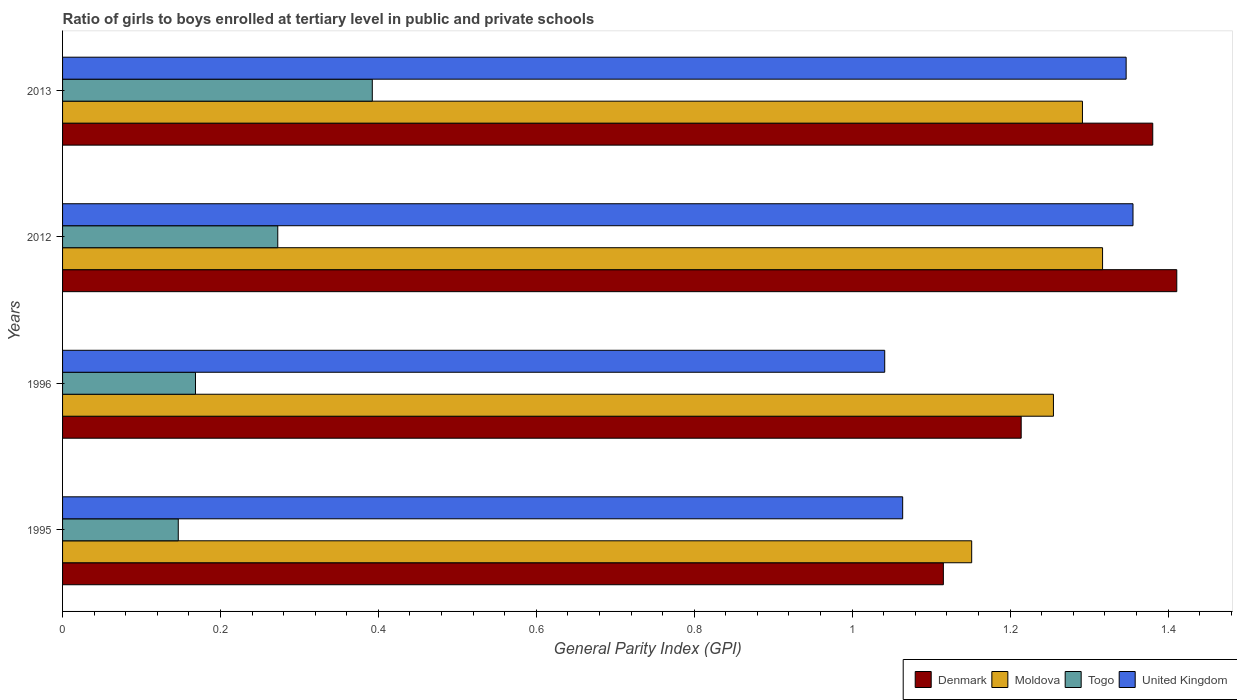How many different coloured bars are there?
Give a very brief answer. 4. Are the number of bars per tick equal to the number of legend labels?
Provide a succinct answer. Yes. Are the number of bars on each tick of the Y-axis equal?
Your answer should be compact. Yes. How many bars are there on the 1st tick from the top?
Provide a short and direct response. 4. How many bars are there on the 3rd tick from the bottom?
Provide a succinct answer. 4. What is the general parity index in Togo in 2013?
Provide a short and direct response. 0.39. Across all years, what is the maximum general parity index in Togo?
Your answer should be compact. 0.39. Across all years, what is the minimum general parity index in Denmark?
Your response must be concise. 1.12. In which year was the general parity index in Denmark minimum?
Offer a very short reply. 1995. What is the total general parity index in United Kingdom in the graph?
Provide a succinct answer. 4.81. What is the difference between the general parity index in United Kingdom in 1996 and that in 2012?
Give a very brief answer. -0.31. What is the difference between the general parity index in Moldova in 1996 and the general parity index in United Kingdom in 2012?
Ensure brevity in your answer.  -0.1. What is the average general parity index in Moldova per year?
Offer a very short reply. 1.25. In the year 2012, what is the difference between the general parity index in Moldova and general parity index in Togo?
Your answer should be very brief. 1.04. What is the ratio of the general parity index in United Kingdom in 1995 to that in 2012?
Keep it short and to the point. 0.78. Is the general parity index in Denmark in 1996 less than that in 2012?
Your answer should be compact. Yes. What is the difference between the highest and the second highest general parity index in Togo?
Offer a very short reply. 0.12. What is the difference between the highest and the lowest general parity index in Denmark?
Your answer should be compact. 0.3. In how many years, is the general parity index in Moldova greater than the average general parity index in Moldova taken over all years?
Make the answer very short. 3. What does the 2nd bar from the bottom in 2012 represents?
Provide a succinct answer. Moldova. Is it the case that in every year, the sum of the general parity index in Denmark and general parity index in United Kingdom is greater than the general parity index in Moldova?
Provide a short and direct response. Yes. How many bars are there?
Your answer should be very brief. 16. Are all the bars in the graph horizontal?
Ensure brevity in your answer.  Yes. What is the difference between two consecutive major ticks on the X-axis?
Provide a short and direct response. 0.2. Are the values on the major ticks of X-axis written in scientific E-notation?
Ensure brevity in your answer.  No. How many legend labels are there?
Offer a very short reply. 4. What is the title of the graph?
Offer a terse response. Ratio of girls to boys enrolled at tertiary level in public and private schools. What is the label or title of the X-axis?
Give a very brief answer. General Parity Index (GPI). What is the General Parity Index (GPI) of Denmark in 1995?
Your response must be concise. 1.12. What is the General Parity Index (GPI) of Moldova in 1995?
Offer a very short reply. 1.15. What is the General Parity Index (GPI) of Togo in 1995?
Offer a terse response. 0.15. What is the General Parity Index (GPI) in United Kingdom in 1995?
Give a very brief answer. 1.06. What is the General Parity Index (GPI) in Denmark in 1996?
Provide a succinct answer. 1.21. What is the General Parity Index (GPI) in Moldova in 1996?
Offer a very short reply. 1.25. What is the General Parity Index (GPI) in Togo in 1996?
Provide a succinct answer. 0.17. What is the General Parity Index (GPI) in United Kingdom in 1996?
Your answer should be compact. 1.04. What is the General Parity Index (GPI) of Denmark in 2012?
Your answer should be compact. 1.41. What is the General Parity Index (GPI) in Moldova in 2012?
Your response must be concise. 1.32. What is the General Parity Index (GPI) of Togo in 2012?
Your answer should be compact. 0.27. What is the General Parity Index (GPI) in United Kingdom in 2012?
Your response must be concise. 1.36. What is the General Parity Index (GPI) in Denmark in 2013?
Offer a terse response. 1.38. What is the General Parity Index (GPI) of Moldova in 2013?
Give a very brief answer. 1.29. What is the General Parity Index (GPI) in Togo in 2013?
Offer a terse response. 0.39. What is the General Parity Index (GPI) of United Kingdom in 2013?
Your answer should be compact. 1.35. Across all years, what is the maximum General Parity Index (GPI) of Denmark?
Ensure brevity in your answer.  1.41. Across all years, what is the maximum General Parity Index (GPI) of Moldova?
Make the answer very short. 1.32. Across all years, what is the maximum General Parity Index (GPI) of Togo?
Your answer should be compact. 0.39. Across all years, what is the maximum General Parity Index (GPI) of United Kingdom?
Provide a short and direct response. 1.36. Across all years, what is the minimum General Parity Index (GPI) in Denmark?
Keep it short and to the point. 1.12. Across all years, what is the minimum General Parity Index (GPI) of Moldova?
Offer a very short reply. 1.15. Across all years, what is the minimum General Parity Index (GPI) in Togo?
Your response must be concise. 0.15. Across all years, what is the minimum General Parity Index (GPI) of United Kingdom?
Give a very brief answer. 1.04. What is the total General Parity Index (GPI) in Denmark in the graph?
Provide a succinct answer. 5.12. What is the total General Parity Index (GPI) in Moldova in the graph?
Offer a very short reply. 5.02. What is the total General Parity Index (GPI) of Togo in the graph?
Give a very brief answer. 0.98. What is the total General Parity Index (GPI) in United Kingdom in the graph?
Provide a short and direct response. 4.81. What is the difference between the General Parity Index (GPI) of Denmark in 1995 and that in 1996?
Provide a short and direct response. -0.1. What is the difference between the General Parity Index (GPI) of Moldova in 1995 and that in 1996?
Your response must be concise. -0.1. What is the difference between the General Parity Index (GPI) of Togo in 1995 and that in 1996?
Your answer should be compact. -0.02. What is the difference between the General Parity Index (GPI) in United Kingdom in 1995 and that in 1996?
Give a very brief answer. 0.02. What is the difference between the General Parity Index (GPI) in Denmark in 1995 and that in 2012?
Your answer should be compact. -0.3. What is the difference between the General Parity Index (GPI) of Moldova in 1995 and that in 2012?
Provide a short and direct response. -0.17. What is the difference between the General Parity Index (GPI) of Togo in 1995 and that in 2012?
Ensure brevity in your answer.  -0.13. What is the difference between the General Parity Index (GPI) of United Kingdom in 1995 and that in 2012?
Make the answer very short. -0.29. What is the difference between the General Parity Index (GPI) of Denmark in 1995 and that in 2013?
Your answer should be very brief. -0.27. What is the difference between the General Parity Index (GPI) of Moldova in 1995 and that in 2013?
Provide a succinct answer. -0.14. What is the difference between the General Parity Index (GPI) of Togo in 1995 and that in 2013?
Provide a succinct answer. -0.25. What is the difference between the General Parity Index (GPI) in United Kingdom in 1995 and that in 2013?
Make the answer very short. -0.28. What is the difference between the General Parity Index (GPI) in Denmark in 1996 and that in 2012?
Your answer should be very brief. -0.2. What is the difference between the General Parity Index (GPI) in Moldova in 1996 and that in 2012?
Your answer should be compact. -0.06. What is the difference between the General Parity Index (GPI) in Togo in 1996 and that in 2012?
Make the answer very short. -0.1. What is the difference between the General Parity Index (GPI) in United Kingdom in 1996 and that in 2012?
Make the answer very short. -0.31. What is the difference between the General Parity Index (GPI) of Denmark in 1996 and that in 2013?
Your answer should be compact. -0.17. What is the difference between the General Parity Index (GPI) of Moldova in 1996 and that in 2013?
Provide a succinct answer. -0.04. What is the difference between the General Parity Index (GPI) of Togo in 1996 and that in 2013?
Your answer should be very brief. -0.22. What is the difference between the General Parity Index (GPI) of United Kingdom in 1996 and that in 2013?
Ensure brevity in your answer.  -0.31. What is the difference between the General Parity Index (GPI) of Denmark in 2012 and that in 2013?
Your answer should be very brief. 0.03. What is the difference between the General Parity Index (GPI) in Moldova in 2012 and that in 2013?
Provide a short and direct response. 0.03. What is the difference between the General Parity Index (GPI) in Togo in 2012 and that in 2013?
Offer a terse response. -0.12. What is the difference between the General Parity Index (GPI) in United Kingdom in 2012 and that in 2013?
Your answer should be compact. 0.01. What is the difference between the General Parity Index (GPI) in Denmark in 1995 and the General Parity Index (GPI) in Moldova in 1996?
Provide a short and direct response. -0.14. What is the difference between the General Parity Index (GPI) of Denmark in 1995 and the General Parity Index (GPI) of Togo in 1996?
Make the answer very short. 0.95. What is the difference between the General Parity Index (GPI) of Denmark in 1995 and the General Parity Index (GPI) of United Kingdom in 1996?
Provide a succinct answer. 0.07. What is the difference between the General Parity Index (GPI) in Moldova in 1995 and the General Parity Index (GPI) in Togo in 1996?
Your response must be concise. 0.98. What is the difference between the General Parity Index (GPI) of Moldova in 1995 and the General Parity Index (GPI) of United Kingdom in 1996?
Provide a succinct answer. 0.11. What is the difference between the General Parity Index (GPI) of Togo in 1995 and the General Parity Index (GPI) of United Kingdom in 1996?
Your answer should be very brief. -0.89. What is the difference between the General Parity Index (GPI) in Denmark in 1995 and the General Parity Index (GPI) in Moldova in 2012?
Give a very brief answer. -0.2. What is the difference between the General Parity Index (GPI) of Denmark in 1995 and the General Parity Index (GPI) of Togo in 2012?
Ensure brevity in your answer.  0.84. What is the difference between the General Parity Index (GPI) in Denmark in 1995 and the General Parity Index (GPI) in United Kingdom in 2012?
Your answer should be compact. -0.24. What is the difference between the General Parity Index (GPI) in Moldova in 1995 and the General Parity Index (GPI) in Togo in 2012?
Ensure brevity in your answer.  0.88. What is the difference between the General Parity Index (GPI) of Moldova in 1995 and the General Parity Index (GPI) of United Kingdom in 2012?
Provide a succinct answer. -0.2. What is the difference between the General Parity Index (GPI) in Togo in 1995 and the General Parity Index (GPI) in United Kingdom in 2012?
Your answer should be very brief. -1.21. What is the difference between the General Parity Index (GPI) of Denmark in 1995 and the General Parity Index (GPI) of Moldova in 2013?
Give a very brief answer. -0.18. What is the difference between the General Parity Index (GPI) in Denmark in 1995 and the General Parity Index (GPI) in Togo in 2013?
Your response must be concise. 0.72. What is the difference between the General Parity Index (GPI) in Denmark in 1995 and the General Parity Index (GPI) in United Kingdom in 2013?
Make the answer very short. -0.23. What is the difference between the General Parity Index (GPI) of Moldova in 1995 and the General Parity Index (GPI) of Togo in 2013?
Offer a very short reply. 0.76. What is the difference between the General Parity Index (GPI) of Moldova in 1995 and the General Parity Index (GPI) of United Kingdom in 2013?
Ensure brevity in your answer.  -0.2. What is the difference between the General Parity Index (GPI) of Togo in 1995 and the General Parity Index (GPI) of United Kingdom in 2013?
Give a very brief answer. -1.2. What is the difference between the General Parity Index (GPI) in Denmark in 1996 and the General Parity Index (GPI) in Moldova in 2012?
Make the answer very short. -0.1. What is the difference between the General Parity Index (GPI) of Denmark in 1996 and the General Parity Index (GPI) of Togo in 2012?
Offer a terse response. 0.94. What is the difference between the General Parity Index (GPI) of Denmark in 1996 and the General Parity Index (GPI) of United Kingdom in 2012?
Ensure brevity in your answer.  -0.14. What is the difference between the General Parity Index (GPI) of Moldova in 1996 and the General Parity Index (GPI) of Togo in 2012?
Make the answer very short. 0.98. What is the difference between the General Parity Index (GPI) of Moldova in 1996 and the General Parity Index (GPI) of United Kingdom in 2012?
Provide a succinct answer. -0.1. What is the difference between the General Parity Index (GPI) of Togo in 1996 and the General Parity Index (GPI) of United Kingdom in 2012?
Provide a short and direct response. -1.19. What is the difference between the General Parity Index (GPI) in Denmark in 1996 and the General Parity Index (GPI) in Moldova in 2013?
Offer a terse response. -0.08. What is the difference between the General Parity Index (GPI) in Denmark in 1996 and the General Parity Index (GPI) in Togo in 2013?
Offer a terse response. 0.82. What is the difference between the General Parity Index (GPI) in Denmark in 1996 and the General Parity Index (GPI) in United Kingdom in 2013?
Provide a short and direct response. -0.13. What is the difference between the General Parity Index (GPI) of Moldova in 1996 and the General Parity Index (GPI) of Togo in 2013?
Keep it short and to the point. 0.86. What is the difference between the General Parity Index (GPI) in Moldova in 1996 and the General Parity Index (GPI) in United Kingdom in 2013?
Make the answer very short. -0.09. What is the difference between the General Parity Index (GPI) of Togo in 1996 and the General Parity Index (GPI) of United Kingdom in 2013?
Offer a very short reply. -1.18. What is the difference between the General Parity Index (GPI) of Denmark in 2012 and the General Parity Index (GPI) of Moldova in 2013?
Provide a succinct answer. 0.12. What is the difference between the General Parity Index (GPI) of Denmark in 2012 and the General Parity Index (GPI) of Togo in 2013?
Your answer should be compact. 1.02. What is the difference between the General Parity Index (GPI) of Denmark in 2012 and the General Parity Index (GPI) of United Kingdom in 2013?
Offer a terse response. 0.06. What is the difference between the General Parity Index (GPI) in Moldova in 2012 and the General Parity Index (GPI) in Togo in 2013?
Make the answer very short. 0.92. What is the difference between the General Parity Index (GPI) of Moldova in 2012 and the General Parity Index (GPI) of United Kingdom in 2013?
Keep it short and to the point. -0.03. What is the difference between the General Parity Index (GPI) in Togo in 2012 and the General Parity Index (GPI) in United Kingdom in 2013?
Your answer should be very brief. -1.07. What is the average General Parity Index (GPI) of Denmark per year?
Offer a very short reply. 1.28. What is the average General Parity Index (GPI) in Moldova per year?
Keep it short and to the point. 1.25. What is the average General Parity Index (GPI) of Togo per year?
Provide a succinct answer. 0.24. What is the average General Parity Index (GPI) in United Kingdom per year?
Your response must be concise. 1.2. In the year 1995, what is the difference between the General Parity Index (GPI) of Denmark and General Parity Index (GPI) of Moldova?
Make the answer very short. -0.04. In the year 1995, what is the difference between the General Parity Index (GPI) of Denmark and General Parity Index (GPI) of Togo?
Your answer should be compact. 0.97. In the year 1995, what is the difference between the General Parity Index (GPI) in Denmark and General Parity Index (GPI) in United Kingdom?
Make the answer very short. 0.05. In the year 1995, what is the difference between the General Parity Index (GPI) of Moldova and General Parity Index (GPI) of United Kingdom?
Make the answer very short. 0.09. In the year 1995, what is the difference between the General Parity Index (GPI) of Togo and General Parity Index (GPI) of United Kingdom?
Give a very brief answer. -0.92. In the year 1996, what is the difference between the General Parity Index (GPI) in Denmark and General Parity Index (GPI) in Moldova?
Your response must be concise. -0.04. In the year 1996, what is the difference between the General Parity Index (GPI) of Denmark and General Parity Index (GPI) of Togo?
Ensure brevity in your answer.  1.05. In the year 1996, what is the difference between the General Parity Index (GPI) in Denmark and General Parity Index (GPI) in United Kingdom?
Give a very brief answer. 0.17. In the year 1996, what is the difference between the General Parity Index (GPI) of Moldova and General Parity Index (GPI) of Togo?
Give a very brief answer. 1.09. In the year 1996, what is the difference between the General Parity Index (GPI) of Moldova and General Parity Index (GPI) of United Kingdom?
Make the answer very short. 0.21. In the year 1996, what is the difference between the General Parity Index (GPI) of Togo and General Parity Index (GPI) of United Kingdom?
Your answer should be very brief. -0.87. In the year 2012, what is the difference between the General Parity Index (GPI) in Denmark and General Parity Index (GPI) in Moldova?
Make the answer very short. 0.09. In the year 2012, what is the difference between the General Parity Index (GPI) in Denmark and General Parity Index (GPI) in Togo?
Give a very brief answer. 1.14. In the year 2012, what is the difference between the General Parity Index (GPI) in Denmark and General Parity Index (GPI) in United Kingdom?
Provide a succinct answer. 0.06. In the year 2012, what is the difference between the General Parity Index (GPI) in Moldova and General Parity Index (GPI) in Togo?
Your answer should be compact. 1.04. In the year 2012, what is the difference between the General Parity Index (GPI) in Moldova and General Parity Index (GPI) in United Kingdom?
Make the answer very short. -0.04. In the year 2012, what is the difference between the General Parity Index (GPI) of Togo and General Parity Index (GPI) of United Kingdom?
Offer a very short reply. -1.08. In the year 2013, what is the difference between the General Parity Index (GPI) in Denmark and General Parity Index (GPI) in Moldova?
Provide a succinct answer. 0.09. In the year 2013, what is the difference between the General Parity Index (GPI) in Denmark and General Parity Index (GPI) in Togo?
Give a very brief answer. 0.99. In the year 2013, what is the difference between the General Parity Index (GPI) in Denmark and General Parity Index (GPI) in United Kingdom?
Your answer should be very brief. 0.03. In the year 2013, what is the difference between the General Parity Index (GPI) of Moldova and General Parity Index (GPI) of Togo?
Your answer should be very brief. 0.9. In the year 2013, what is the difference between the General Parity Index (GPI) of Moldova and General Parity Index (GPI) of United Kingdom?
Offer a terse response. -0.06. In the year 2013, what is the difference between the General Parity Index (GPI) of Togo and General Parity Index (GPI) of United Kingdom?
Your answer should be compact. -0.95. What is the ratio of the General Parity Index (GPI) in Denmark in 1995 to that in 1996?
Offer a terse response. 0.92. What is the ratio of the General Parity Index (GPI) in Moldova in 1995 to that in 1996?
Make the answer very short. 0.92. What is the ratio of the General Parity Index (GPI) of Togo in 1995 to that in 1996?
Ensure brevity in your answer.  0.87. What is the ratio of the General Parity Index (GPI) of United Kingdom in 1995 to that in 1996?
Offer a terse response. 1.02. What is the ratio of the General Parity Index (GPI) in Denmark in 1995 to that in 2012?
Offer a terse response. 0.79. What is the ratio of the General Parity Index (GPI) of Moldova in 1995 to that in 2012?
Your response must be concise. 0.87. What is the ratio of the General Parity Index (GPI) of Togo in 1995 to that in 2012?
Your answer should be compact. 0.54. What is the ratio of the General Parity Index (GPI) of United Kingdom in 1995 to that in 2012?
Provide a succinct answer. 0.78. What is the ratio of the General Parity Index (GPI) of Denmark in 1995 to that in 2013?
Offer a very short reply. 0.81. What is the ratio of the General Parity Index (GPI) in Moldova in 1995 to that in 2013?
Provide a short and direct response. 0.89. What is the ratio of the General Parity Index (GPI) of Togo in 1995 to that in 2013?
Your response must be concise. 0.37. What is the ratio of the General Parity Index (GPI) of United Kingdom in 1995 to that in 2013?
Your response must be concise. 0.79. What is the ratio of the General Parity Index (GPI) of Denmark in 1996 to that in 2012?
Offer a very short reply. 0.86. What is the ratio of the General Parity Index (GPI) of Moldova in 1996 to that in 2012?
Keep it short and to the point. 0.95. What is the ratio of the General Parity Index (GPI) in Togo in 1996 to that in 2012?
Ensure brevity in your answer.  0.62. What is the ratio of the General Parity Index (GPI) in United Kingdom in 1996 to that in 2012?
Your answer should be very brief. 0.77. What is the ratio of the General Parity Index (GPI) in Denmark in 1996 to that in 2013?
Keep it short and to the point. 0.88. What is the ratio of the General Parity Index (GPI) in Moldova in 1996 to that in 2013?
Ensure brevity in your answer.  0.97. What is the ratio of the General Parity Index (GPI) in Togo in 1996 to that in 2013?
Make the answer very short. 0.43. What is the ratio of the General Parity Index (GPI) of United Kingdom in 1996 to that in 2013?
Offer a terse response. 0.77. What is the ratio of the General Parity Index (GPI) of Denmark in 2012 to that in 2013?
Keep it short and to the point. 1.02. What is the ratio of the General Parity Index (GPI) of Moldova in 2012 to that in 2013?
Keep it short and to the point. 1.02. What is the ratio of the General Parity Index (GPI) of Togo in 2012 to that in 2013?
Offer a terse response. 0.69. What is the ratio of the General Parity Index (GPI) in United Kingdom in 2012 to that in 2013?
Provide a short and direct response. 1.01. What is the difference between the highest and the second highest General Parity Index (GPI) of Denmark?
Your answer should be very brief. 0.03. What is the difference between the highest and the second highest General Parity Index (GPI) in Moldova?
Provide a short and direct response. 0.03. What is the difference between the highest and the second highest General Parity Index (GPI) of Togo?
Provide a succinct answer. 0.12. What is the difference between the highest and the second highest General Parity Index (GPI) in United Kingdom?
Offer a terse response. 0.01. What is the difference between the highest and the lowest General Parity Index (GPI) of Denmark?
Offer a terse response. 0.3. What is the difference between the highest and the lowest General Parity Index (GPI) in Moldova?
Offer a very short reply. 0.17. What is the difference between the highest and the lowest General Parity Index (GPI) in Togo?
Give a very brief answer. 0.25. What is the difference between the highest and the lowest General Parity Index (GPI) in United Kingdom?
Give a very brief answer. 0.31. 